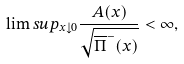<formula> <loc_0><loc_0><loc_500><loc_500>\lim s u p _ { x \downarrow 0 } \frac { A ( x ) } { \sqrt { \overline { \Pi } ^ { - } ( x ) } } < \infty ,</formula> 